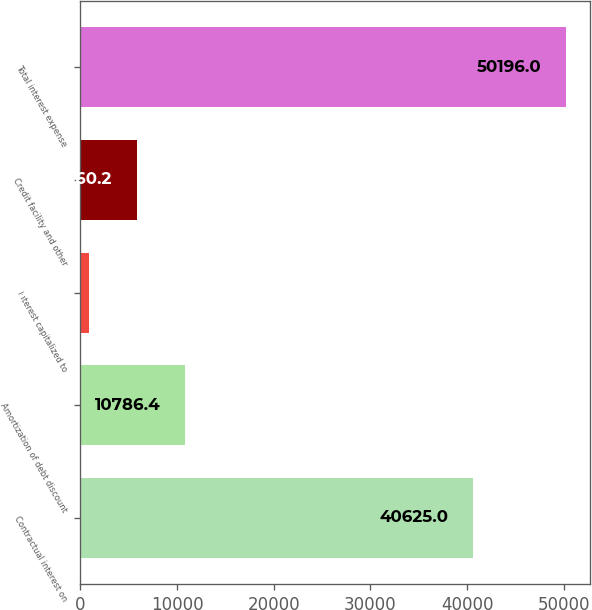Convert chart to OTSL. <chart><loc_0><loc_0><loc_500><loc_500><bar_chart><fcel>Contractual interest on<fcel>Amortization of debt discount<fcel>Interest capitalized to<fcel>Credit facility and other<fcel>Total interest expense<nl><fcel>40625<fcel>10786.4<fcel>934<fcel>5860.2<fcel>50196<nl></chart> 